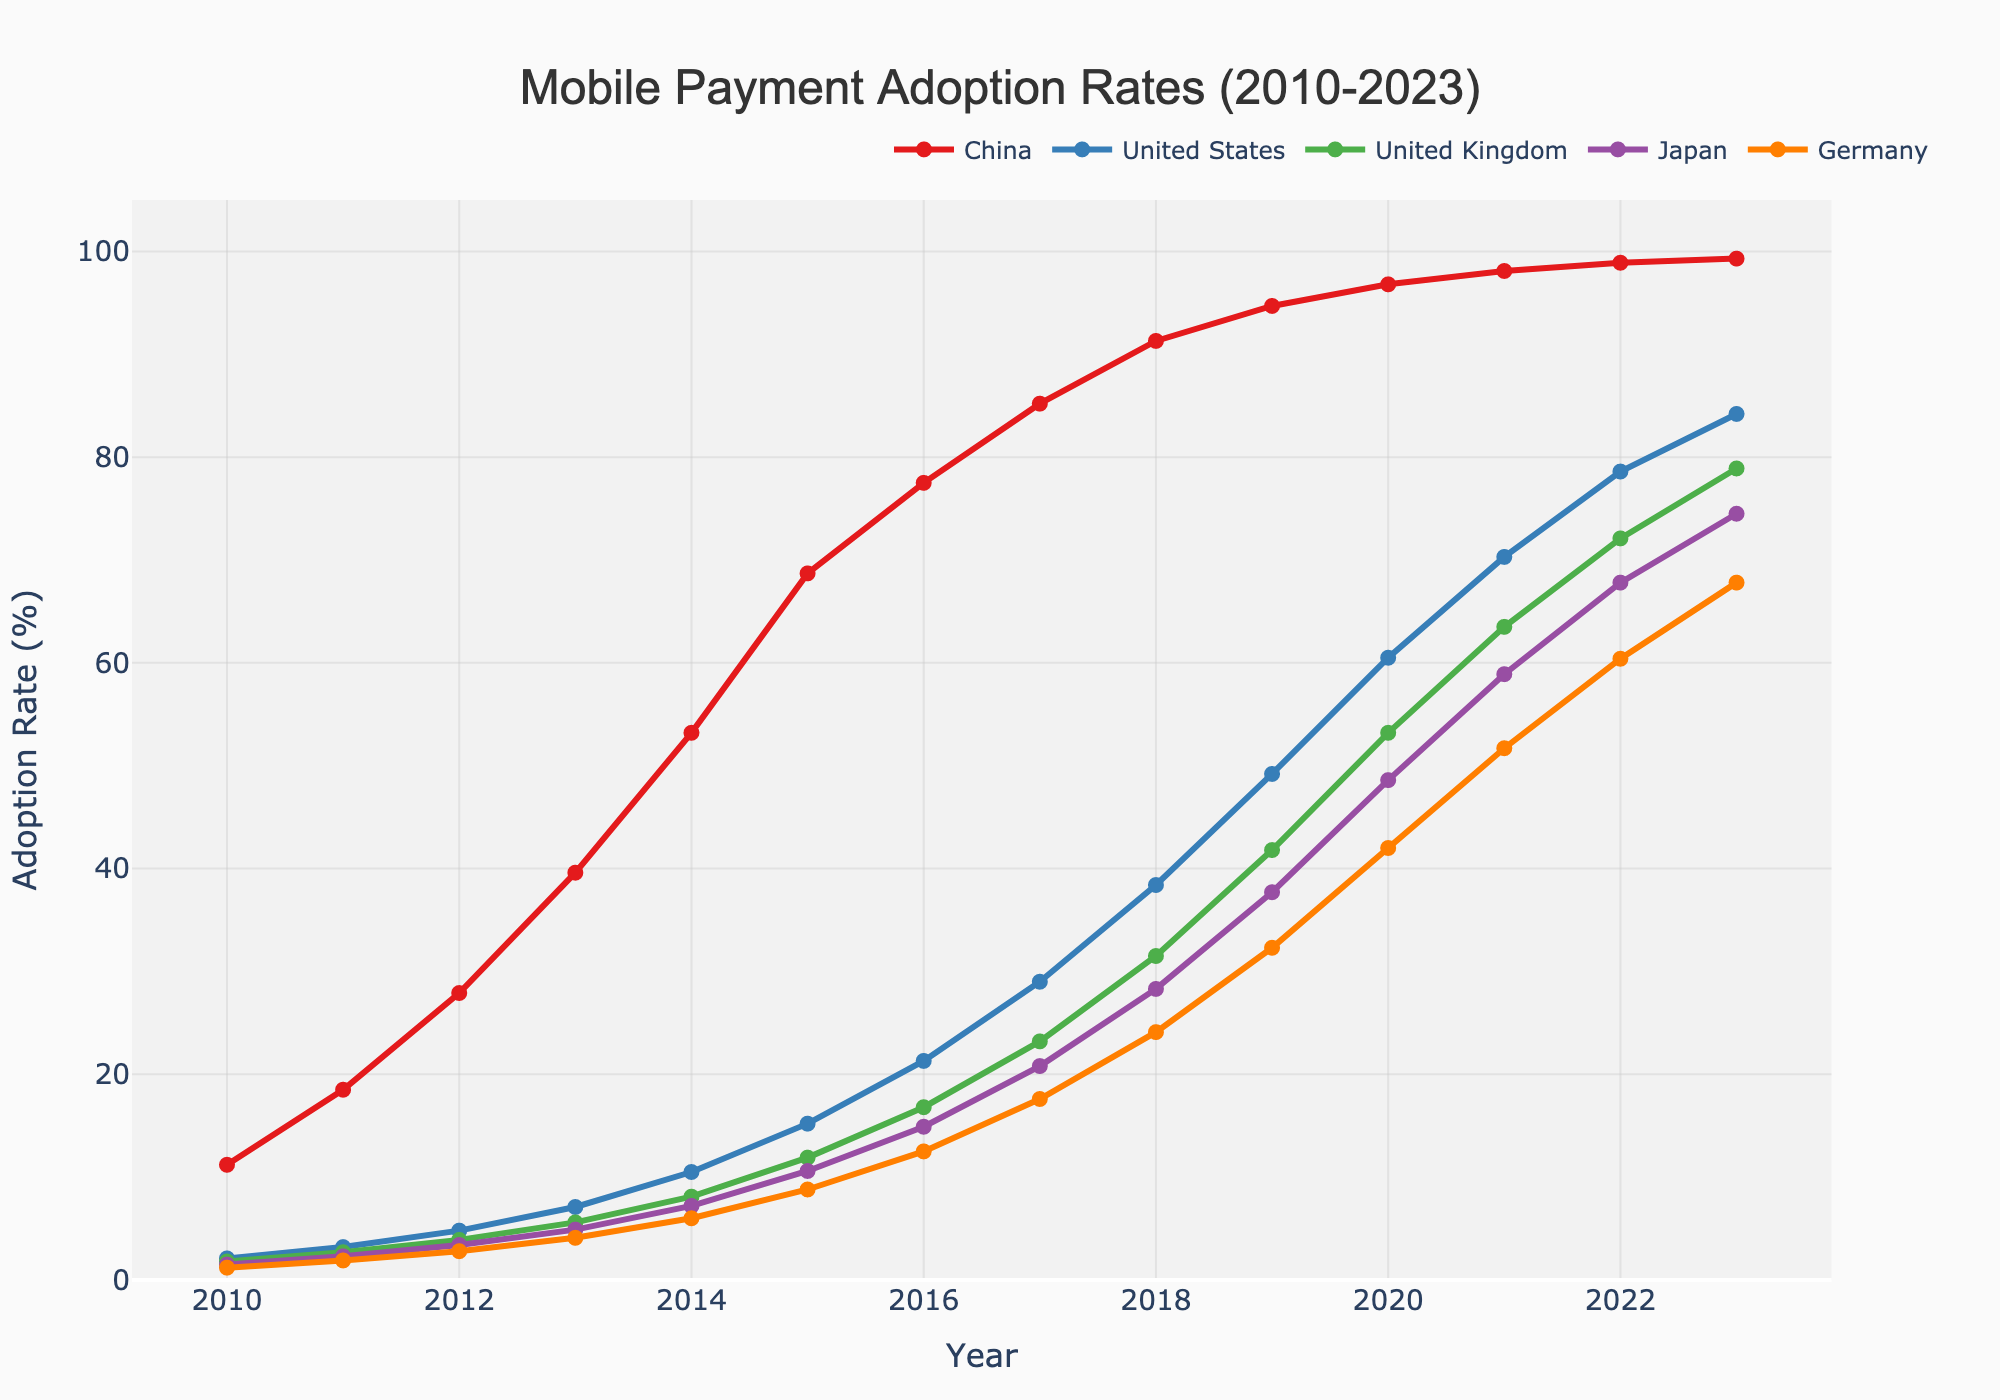What was the adoption rate of mobile payments in China in 2015? Look at the point on the line representing China for the year 2015. Read the Y-axis value for that point.
Answer: 68.7% How does the mobile payment adoption rate in the United States in 2020 compare to that in Japan? Find the points on the lines for the United States and Japan in the year 2020. Compare their Y-axis values. The United States has a higher adoption rate compared to Japan in 2020.
Answer: The United States is higher Which country had the lowest adoption rate of mobile payments in 2011? Look at the points on the lines for all countries in 2011 and find the one with the lowest Y-axis value.
Answer: Germany By how many percentage points did China's adoption rate increase from 2013 to 2014? Find the points on the line for China in 2013 and 2014. Subtract the 2013 value from the 2014 value to get the difference. 53.2% - 39.6% = 13.6%.
Answer: 13.6% Calculate the average adoption rate of mobile payments for Germany from 2010 to 2023. Add up all the adoption rates for Germany from 2010 to 2023 and divide by the number of years. (1.2 + 1.9 + 2.8 + 4.1 + 6.0 + 8.8 + 12.5 + 17.6 + 24.1 + 32.3 + 42.0 + 51.7 + 60.4 + 67.8) / 14 = 28.93%
Answer: 28.93% In which year did the United States surpass a 50% adoption rate of mobile payments? Look at the line for the United States and identify the year at which it first exceeds the 50% mark on the Y-axis.
Answer: 2020 Compare the mobile payment adoption rates of China and the United Kingdom in 2019. Look at the points on the lines for China and the United Kingdom in 2019. Compare their Y-axis values. 94.7% (China) and 41.8% (UK). China has a higher rate.
Answer: China is higher What is the visual difference in marker styles used in the plot? The plot uses markers on each data point, which include size and the shape of the marker dots. Each country's line has circle-shaped markers.
Answer: Circle markers By how many percentage points did Japan's mobile payment adoption rate increase from 2015 to 2023? Find the points on the line for Japan in 2015 and 2023. Subtract the 2015 value from the 2023 value. 74.5% - 10.6% = 63.9%.
Answer: 63.9% Which country shows the most gradual increase in mobile payment adoption rates over the years? Observe the slopes of the lines for all the countries. The line with the smallest and most consistent slope represents the most gradual increase. This appears to be Germany.
Answer: Germany 